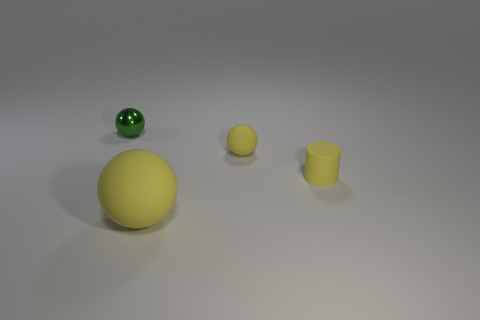What is the color of the small object that is on the left side of the matte sphere that is right of the yellow sphere that is in front of the tiny yellow cylinder?
Offer a terse response. Green. There is a green thing; does it have the same size as the yellow matte thing behind the cylinder?
Provide a short and direct response. Yes. What number of objects are either rubber balls on the right side of the large yellow thing or tiny balls that are in front of the metallic object?
Your response must be concise. 1. There is a green metallic thing that is the same size as the matte cylinder; what is its shape?
Your response must be concise. Sphere. There is a large thing that is in front of the yellow sphere that is on the right side of the yellow rubber thing that is in front of the small yellow rubber cylinder; what shape is it?
Provide a short and direct response. Sphere. Is the number of small yellow matte spheres on the left side of the large yellow object the same as the number of tiny yellow balls?
Make the answer very short. No. Is the matte cylinder the same size as the green thing?
Offer a very short reply. Yes. How many shiny objects are either tiny balls or large yellow objects?
Offer a terse response. 1. There is a green object that is the same size as the yellow cylinder; what material is it?
Make the answer very short. Metal. What number of other objects are the same material as the tiny green ball?
Offer a very short reply. 0. 